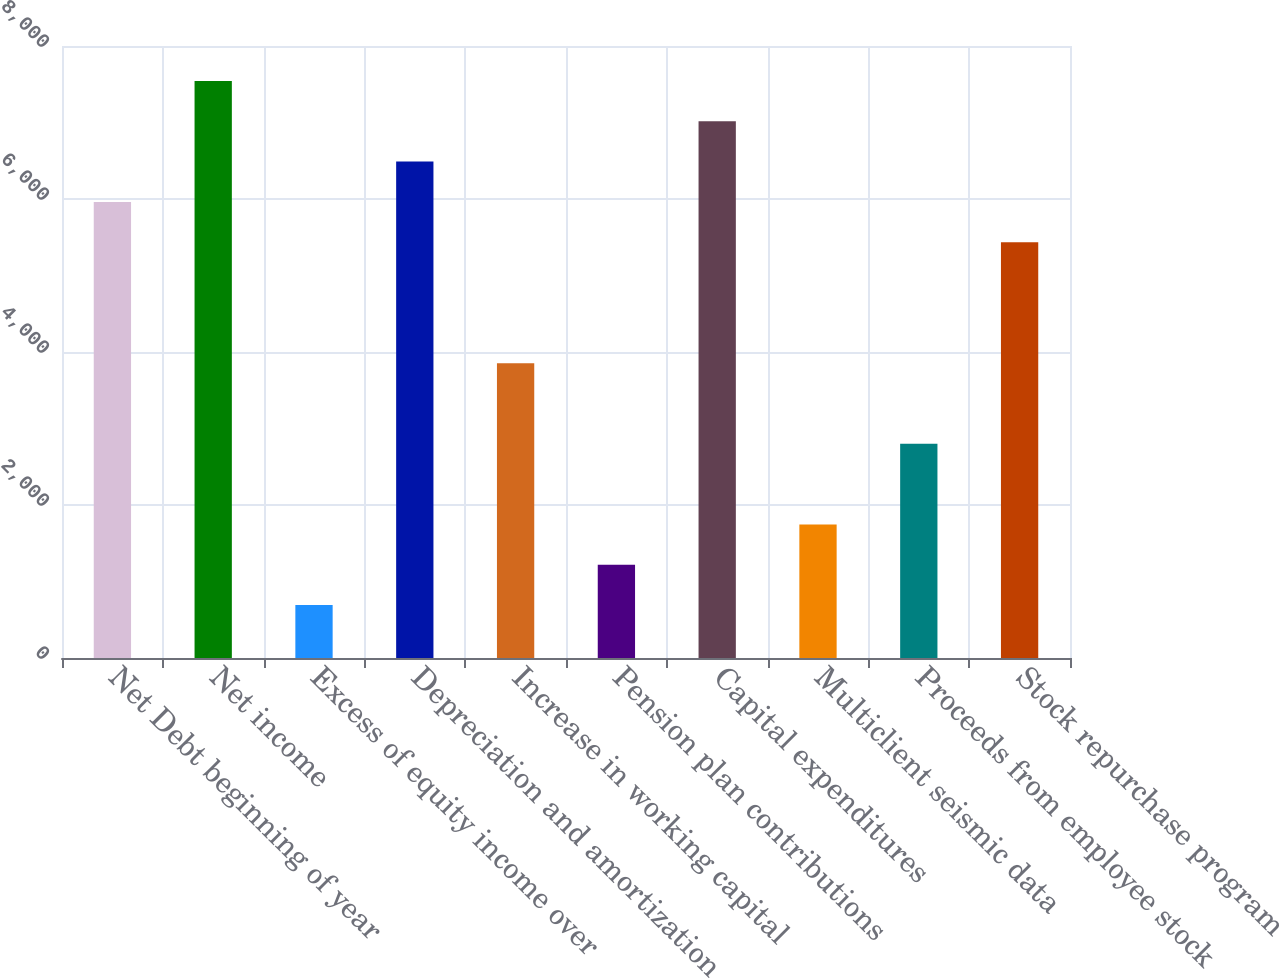Convert chart. <chart><loc_0><loc_0><loc_500><loc_500><bar_chart><fcel>Net Debt beginning of year<fcel>Net income<fcel>Excess of equity income over<fcel>Depreciation and amortization<fcel>Increase in working capital<fcel>Pension plan contributions<fcel>Capital expenditures<fcel>Multiclient seismic data<fcel>Proceeds from employee stock<fcel>Stock repurchase program<nl><fcel>5961.9<fcel>7542.6<fcel>692.9<fcel>6488.8<fcel>3854.3<fcel>1219.8<fcel>7015.7<fcel>1746.7<fcel>2800.5<fcel>5435<nl></chart> 